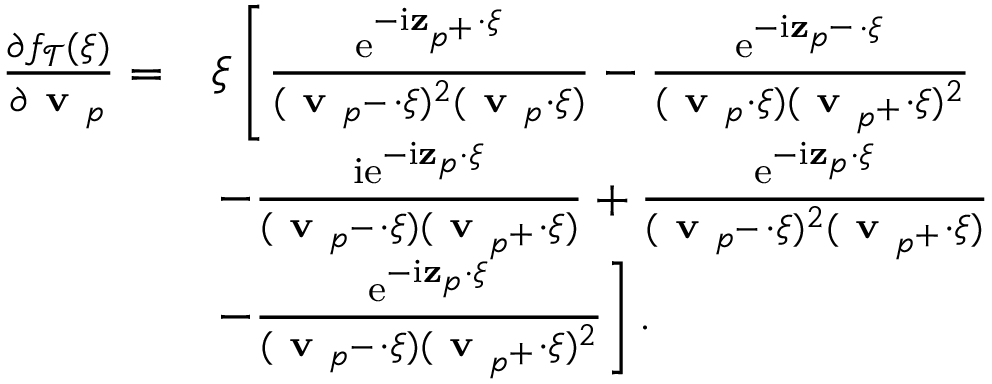Convert formula to latex. <formula><loc_0><loc_0><loc_500><loc_500>\begin{array} { r l } { \frac { \partial f _ { \mathcal { T } } ( \xi ) } { \partial v _ { p } } = } & { \xi \left [ \frac { e ^ { - i z _ { p ^ { + } } \cdot \xi } } { ( v _ { p ^ { - } } \cdot \xi ) ^ { 2 } ( v _ { p } \cdot \xi ) } - \frac { e ^ { - i z _ { p ^ { - } } \cdot \xi } } { ( v _ { p } \cdot \xi ) ( v _ { p ^ { + } } \cdot \xi ) ^ { 2 } } } \\ & { - \frac { i e ^ { - i z _ { p } \cdot \xi } } { ( v _ { p ^ { - } } \cdot \xi ) ( v _ { p ^ { + } } \cdot \xi ) } + \frac { e ^ { - i z _ { p } \cdot \xi } } { ( v _ { p ^ { - } } \cdot \xi ) ^ { 2 } ( v _ { p ^ { + } } \cdot \xi ) } } \\ & { - \frac { e ^ { - i z _ { p } \cdot \xi } } { ( v _ { p ^ { - } } \cdot \xi ) ( v _ { p ^ { + } } \cdot \xi ) ^ { 2 } } \right ] . } \end{array}</formula> 